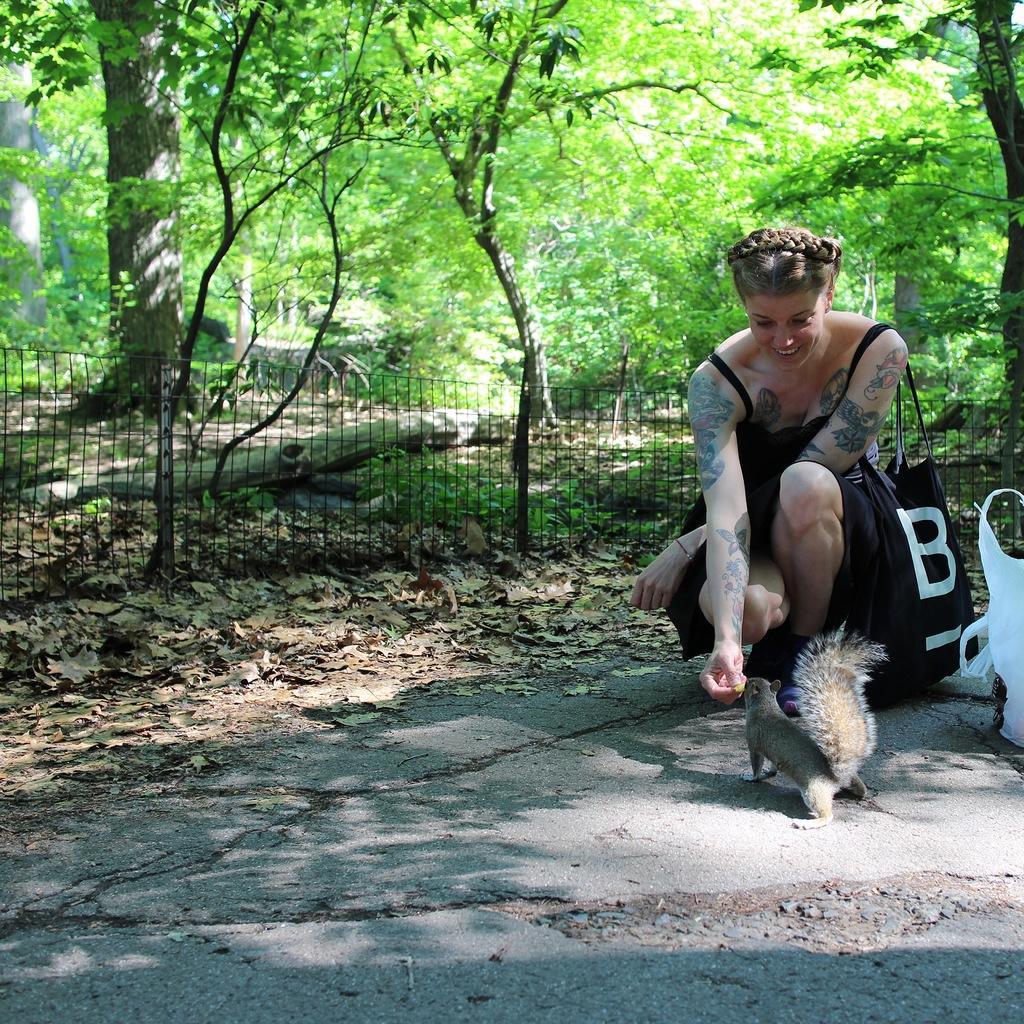How would you summarize this image in a sentence or two? In this image, we can see a person wearing clothes and bag. There is a fence in front of trees. There is a road at the bottom of the image. There is a plastic bag and squirrel on the right side of the image. 